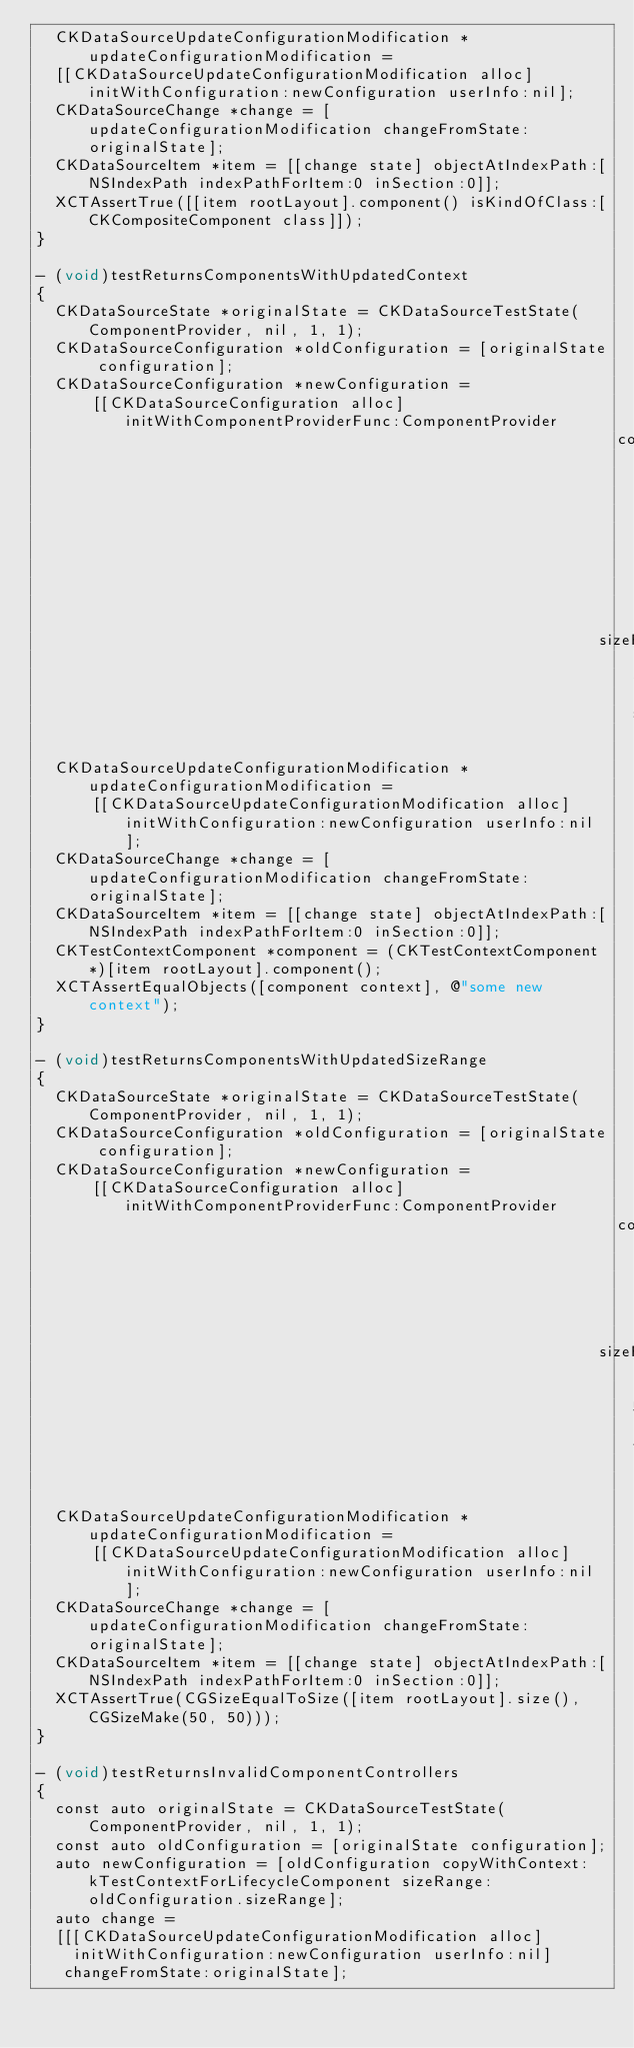<code> <loc_0><loc_0><loc_500><loc_500><_ObjectiveC_>  CKDataSourceUpdateConfigurationModification *updateConfigurationModification =
  [[CKDataSourceUpdateConfigurationModification alloc] initWithConfiguration:newConfiguration userInfo:nil];
  CKDataSourceChange *change = [updateConfigurationModification changeFromState:originalState];
  CKDataSourceItem *item = [[change state] objectAtIndexPath:[NSIndexPath indexPathForItem:0 inSection:0]];
  XCTAssertTrue([[item rootLayout].component() isKindOfClass:[CKCompositeComponent class]]);
}

- (void)testReturnsComponentsWithUpdatedContext
{
  CKDataSourceState *originalState = CKDataSourceTestState(ComponentProvider, nil, 1, 1);
  CKDataSourceConfiguration *oldConfiguration = [originalState configuration];
  CKDataSourceConfiguration *newConfiguration =
      [[CKDataSourceConfiguration alloc] initWithComponentProviderFunc:ComponentProvider
                                                               context:@"some new context"
                                                             sizeRange:[oldConfiguration sizeRange]];
  CKDataSourceUpdateConfigurationModification *updateConfigurationModification =
      [[CKDataSourceUpdateConfigurationModification alloc] initWithConfiguration:newConfiguration userInfo:nil];
  CKDataSourceChange *change = [updateConfigurationModification changeFromState:originalState];
  CKDataSourceItem *item = [[change state] objectAtIndexPath:[NSIndexPath indexPathForItem:0 inSection:0]];
  CKTestContextComponent *component = (CKTestContextComponent *)[item rootLayout].component();
  XCTAssertEqualObjects([component context], @"some new context");
}

- (void)testReturnsComponentsWithUpdatedSizeRange
{
  CKDataSourceState *originalState = CKDataSourceTestState(ComponentProvider, nil, 1, 1);
  CKDataSourceConfiguration *oldConfiguration = [originalState configuration];
  CKDataSourceConfiguration *newConfiguration =
      [[CKDataSourceConfiguration alloc] initWithComponentProviderFunc:ComponentProvider
                                                               context:[oldConfiguration context]
                                                             sizeRange:{{50, 50}, {50, 50}}];
  CKDataSourceUpdateConfigurationModification *updateConfigurationModification =
      [[CKDataSourceUpdateConfigurationModification alloc] initWithConfiguration:newConfiguration userInfo:nil];
  CKDataSourceChange *change = [updateConfigurationModification changeFromState:originalState];
  CKDataSourceItem *item = [[change state] objectAtIndexPath:[NSIndexPath indexPathForItem:0 inSection:0]];
  XCTAssertTrue(CGSizeEqualToSize([item rootLayout].size(), CGSizeMake(50, 50)));
}

- (void)testReturnsInvalidComponentControllers
{
  const auto originalState = CKDataSourceTestState(ComponentProvider, nil, 1, 1);
  const auto oldConfiguration = [originalState configuration];
  auto newConfiguration = [oldConfiguration copyWithContext:kTestContextForLifecycleComponent sizeRange:oldConfiguration.sizeRange];
  auto change =
  [[[CKDataSourceUpdateConfigurationModification alloc]
    initWithConfiguration:newConfiguration userInfo:nil]
   changeFromState:originalState];
</code> 